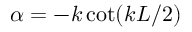Convert formula to latex. <formula><loc_0><loc_0><loc_500><loc_500>\alpha = - k \cot ( k L / 2 )</formula> 